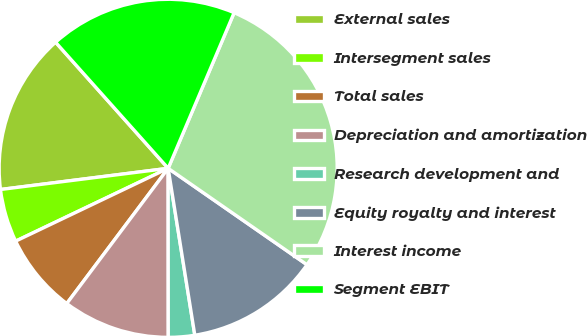Convert chart to OTSL. <chart><loc_0><loc_0><loc_500><loc_500><pie_chart><fcel>External sales<fcel>Intersegment sales<fcel>Total sales<fcel>Depreciation and amortization<fcel>Research development and<fcel>Equity royalty and interest<fcel>Interest income<fcel>Segment EBIT<nl><fcel>15.4%<fcel>5.09%<fcel>7.67%<fcel>10.25%<fcel>2.51%<fcel>12.82%<fcel>28.28%<fcel>17.98%<nl></chart> 